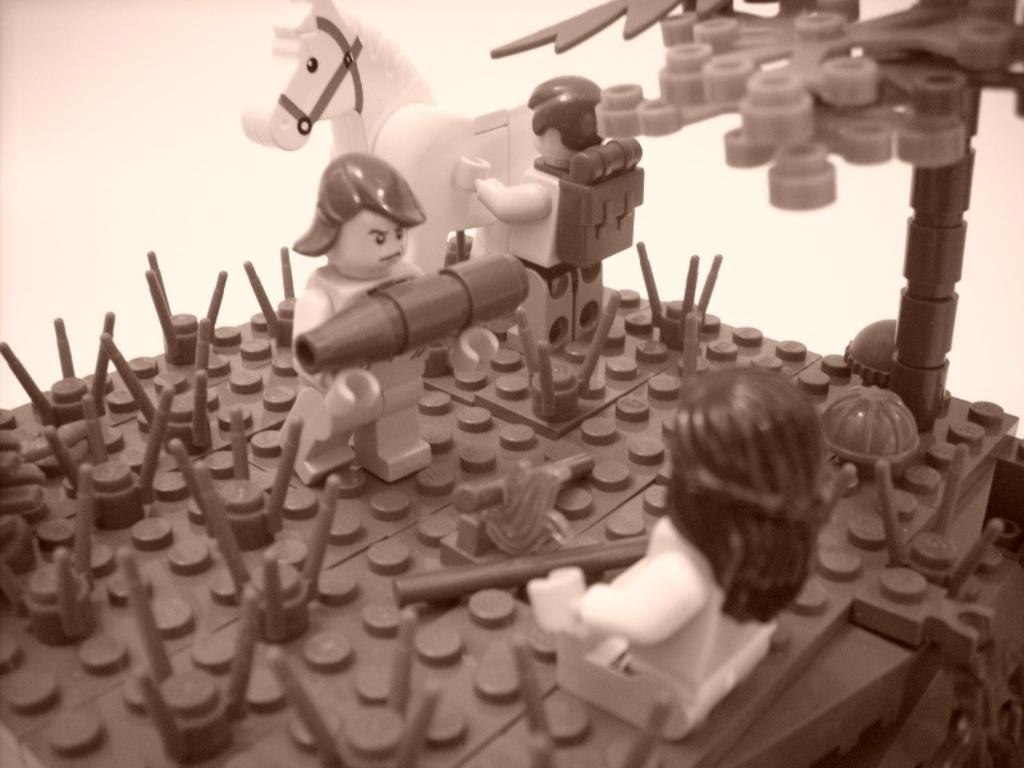What type of objects are present in the image? There are lego cubes, toys in the shape of people, and toys in the shape of animals in the image. What is the purpose of the pole in the image? The purpose of the pole in the image is not specified, but it could be used for support or as part of a structure. Where is the shop located in the image? There is no shop present in the image. What type of bean is being used to build the lego structure in the image? There are no beans present in the image; it features lego cubes and toys. 